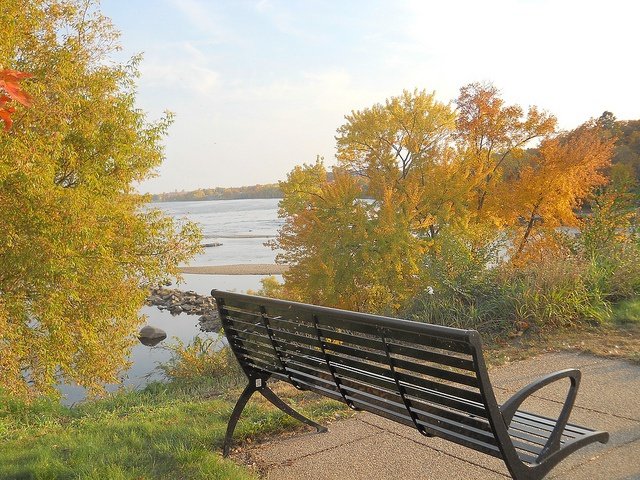Describe the objects in this image and their specific colors. I can see a bench in olive, black, gray, and darkgray tones in this image. 